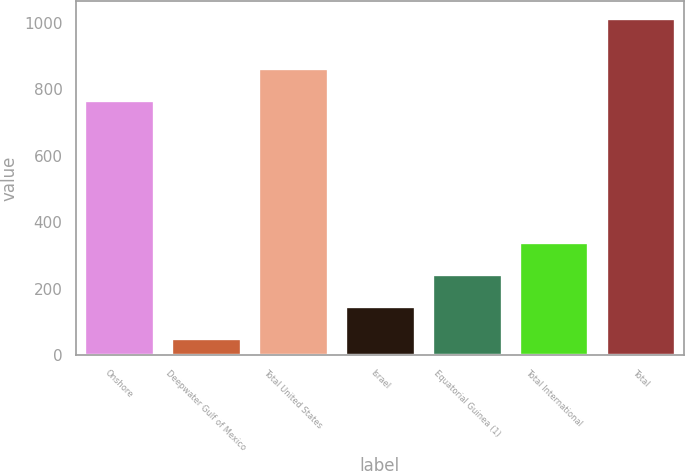Convert chart. <chart><loc_0><loc_0><loc_500><loc_500><bar_chart><fcel>Onshore<fcel>Deepwater Gulf of Mexico<fcel>Total United States<fcel>Israel<fcel>Equatorial Guinea (1)<fcel>Total International<fcel>Total<nl><fcel>768<fcel>51<fcel>864.4<fcel>147.4<fcel>243.8<fcel>340.2<fcel>1015<nl></chart> 